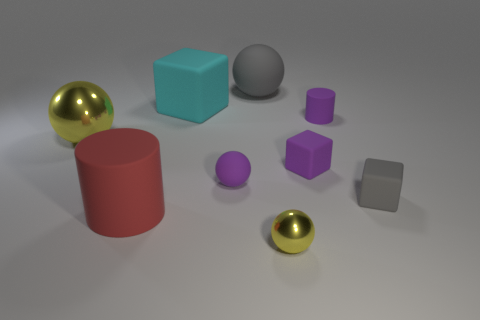Add 1 big green shiny spheres. How many objects exist? 10 Subtract all cubes. How many objects are left? 6 Add 2 small yellow metallic things. How many small yellow metallic things exist? 3 Subtract 0 blue spheres. How many objects are left? 9 Subtract all small yellow spheres. Subtract all red things. How many objects are left? 7 Add 7 gray rubber cubes. How many gray rubber cubes are left? 8 